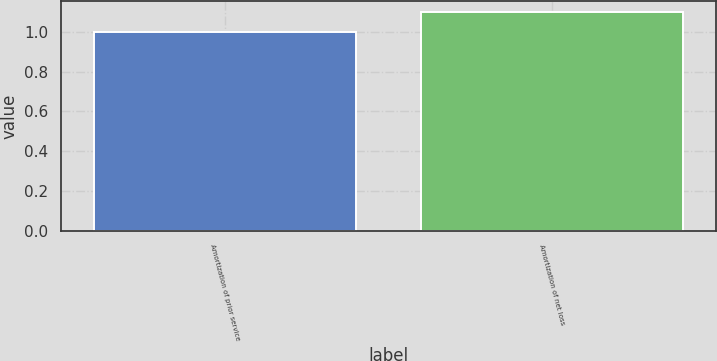Convert chart. <chart><loc_0><loc_0><loc_500><loc_500><bar_chart><fcel>Amortization of prior service<fcel>Amortization of net loss<nl><fcel>1<fcel>1.1<nl></chart> 